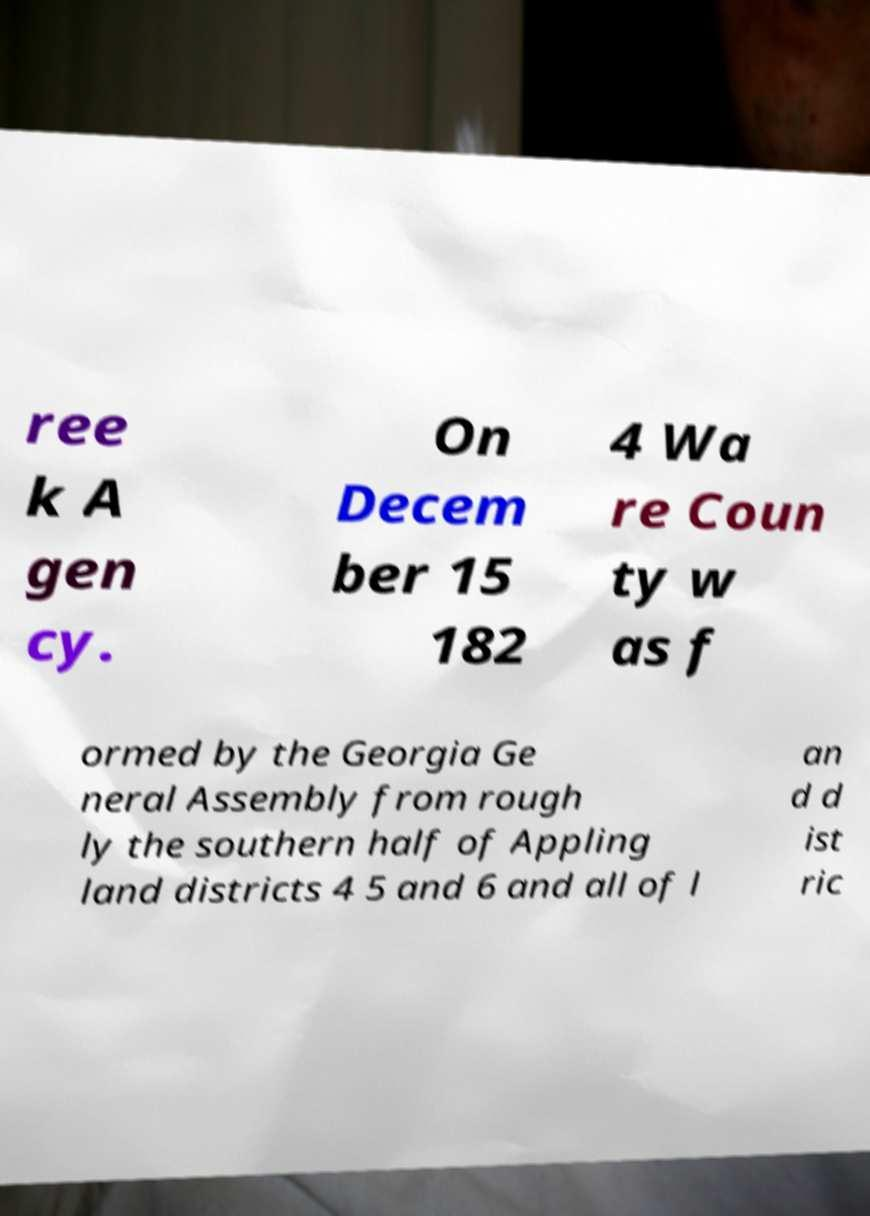Can you read and provide the text displayed in the image?This photo seems to have some interesting text. Can you extract and type it out for me? ree k A gen cy. On Decem ber 15 182 4 Wa re Coun ty w as f ormed by the Georgia Ge neral Assembly from rough ly the southern half of Appling land districts 4 5 and 6 and all of l an d d ist ric 